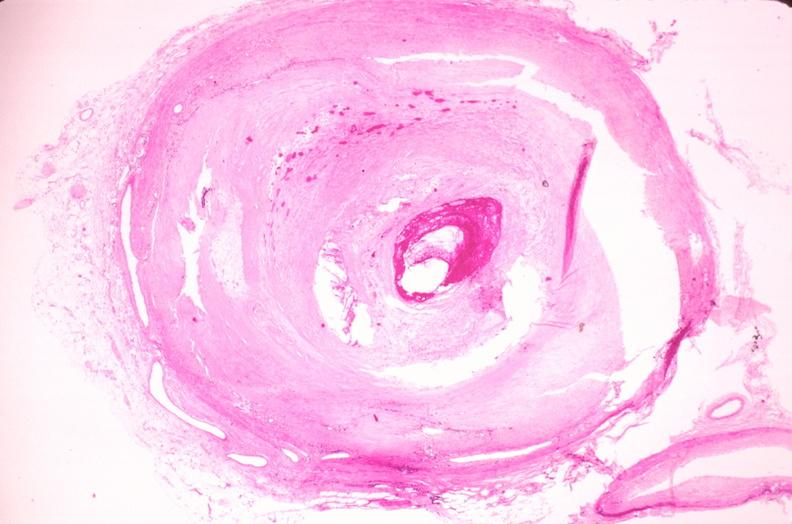does sacrococcygeal teratoma show coronary artery atherosclerosis?
Answer the question using a single word or phrase. No 